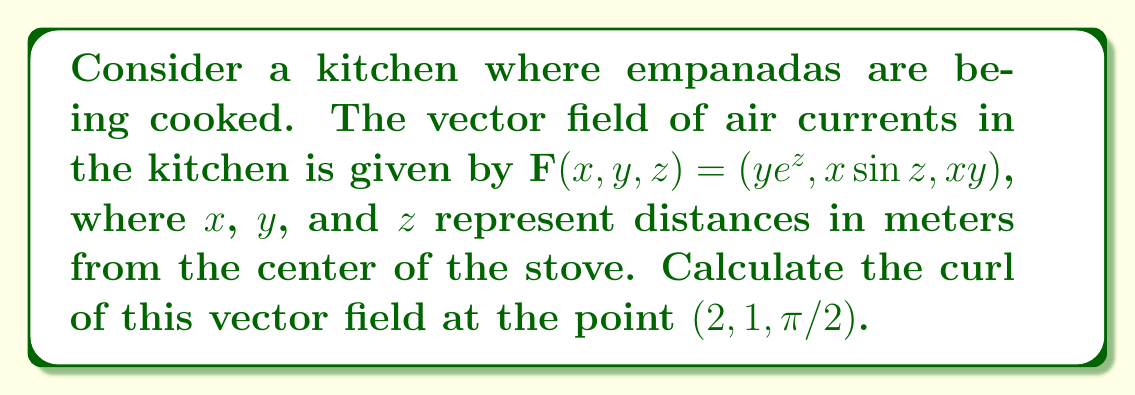Can you answer this question? To find the curl of the vector field, we need to follow these steps:

1) The curl of a vector field $\mathbf{F}(x,y,z) = (F_1, F_2, F_3)$ is given by:

   $$\text{curl }\mathbf{F} = \nabla \times \mathbf{F} = \left(\frac{\partial F_3}{\partial y} - \frac{\partial F_2}{\partial z}, \frac{\partial F_1}{\partial z} - \frac{\partial F_3}{\partial x}, \frac{\partial F_2}{\partial x} - \frac{\partial F_1}{\partial y}\right)$$

2) For our vector field $\mathbf{F}(x,y,z) = (ye^z, x\sin z, xy)$, we have:
   $F_1 = ye^z$, $F_2 = x\sin z$, $F_3 = xy$

3) Let's calculate each partial derivative:

   $\frac{\partial F_3}{\partial y} = x$
   $\frac{\partial F_2}{\partial z} = x\cos z$
   $\frac{\partial F_1}{\partial z} = ye^z$
   $\frac{\partial F_3}{\partial x} = y$
   $\frac{\partial F_2}{\partial x} = \sin z$
   $\frac{\partial F_1}{\partial y} = e^z$

4) Now we can form the curl:

   $$\text{curl }\mathbf{F} = (x - x\cos z, ye^z - y, \sin z - e^z)$$

5) We need to evaluate this at the point $(2, 1, \pi/2)$:

   $$\text{curl }\mathbf{F}(2,1,\pi/2) = (2 - 2\cos(\pi/2), e^{\pi/2} - 1, \sin(\pi/2) - e^{\pi/2})$$

6) Simplify:
   $\cos(\pi/2) = 0$, $\sin(\pi/2) = 1$

   $$\text{curl }\mathbf{F}(2,1,\pi/2) = (2, e^{\pi/2} - 1, 1 - e^{\pi/2})$$
Answer: $(2, e^{\pi/2} - 1, 1 - e^{\pi/2})$ 